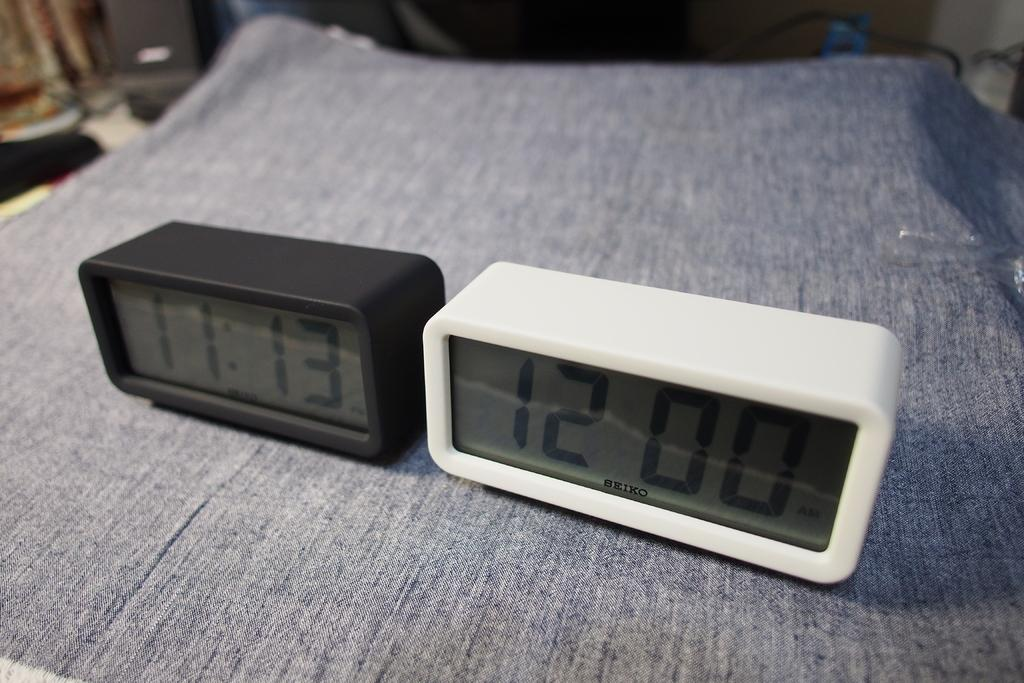<image>
Provide a brief description of the given image. Two clocks sit side by side, one saying 11:13 and the other saying 12:00. 